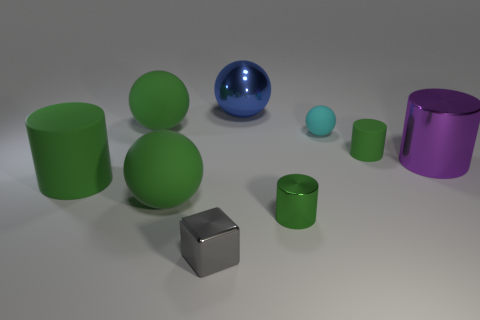Subtract all brown balls. How many green cylinders are left? 3 Subtract all red balls. Subtract all brown cylinders. How many balls are left? 4 Add 1 big rubber cylinders. How many objects exist? 10 Subtract all spheres. How many objects are left? 5 Subtract all tiny matte cubes. Subtract all green rubber spheres. How many objects are left? 7 Add 6 green cylinders. How many green cylinders are left? 9 Add 4 small shiny cylinders. How many small shiny cylinders exist? 5 Subtract 0 blue cylinders. How many objects are left? 9 